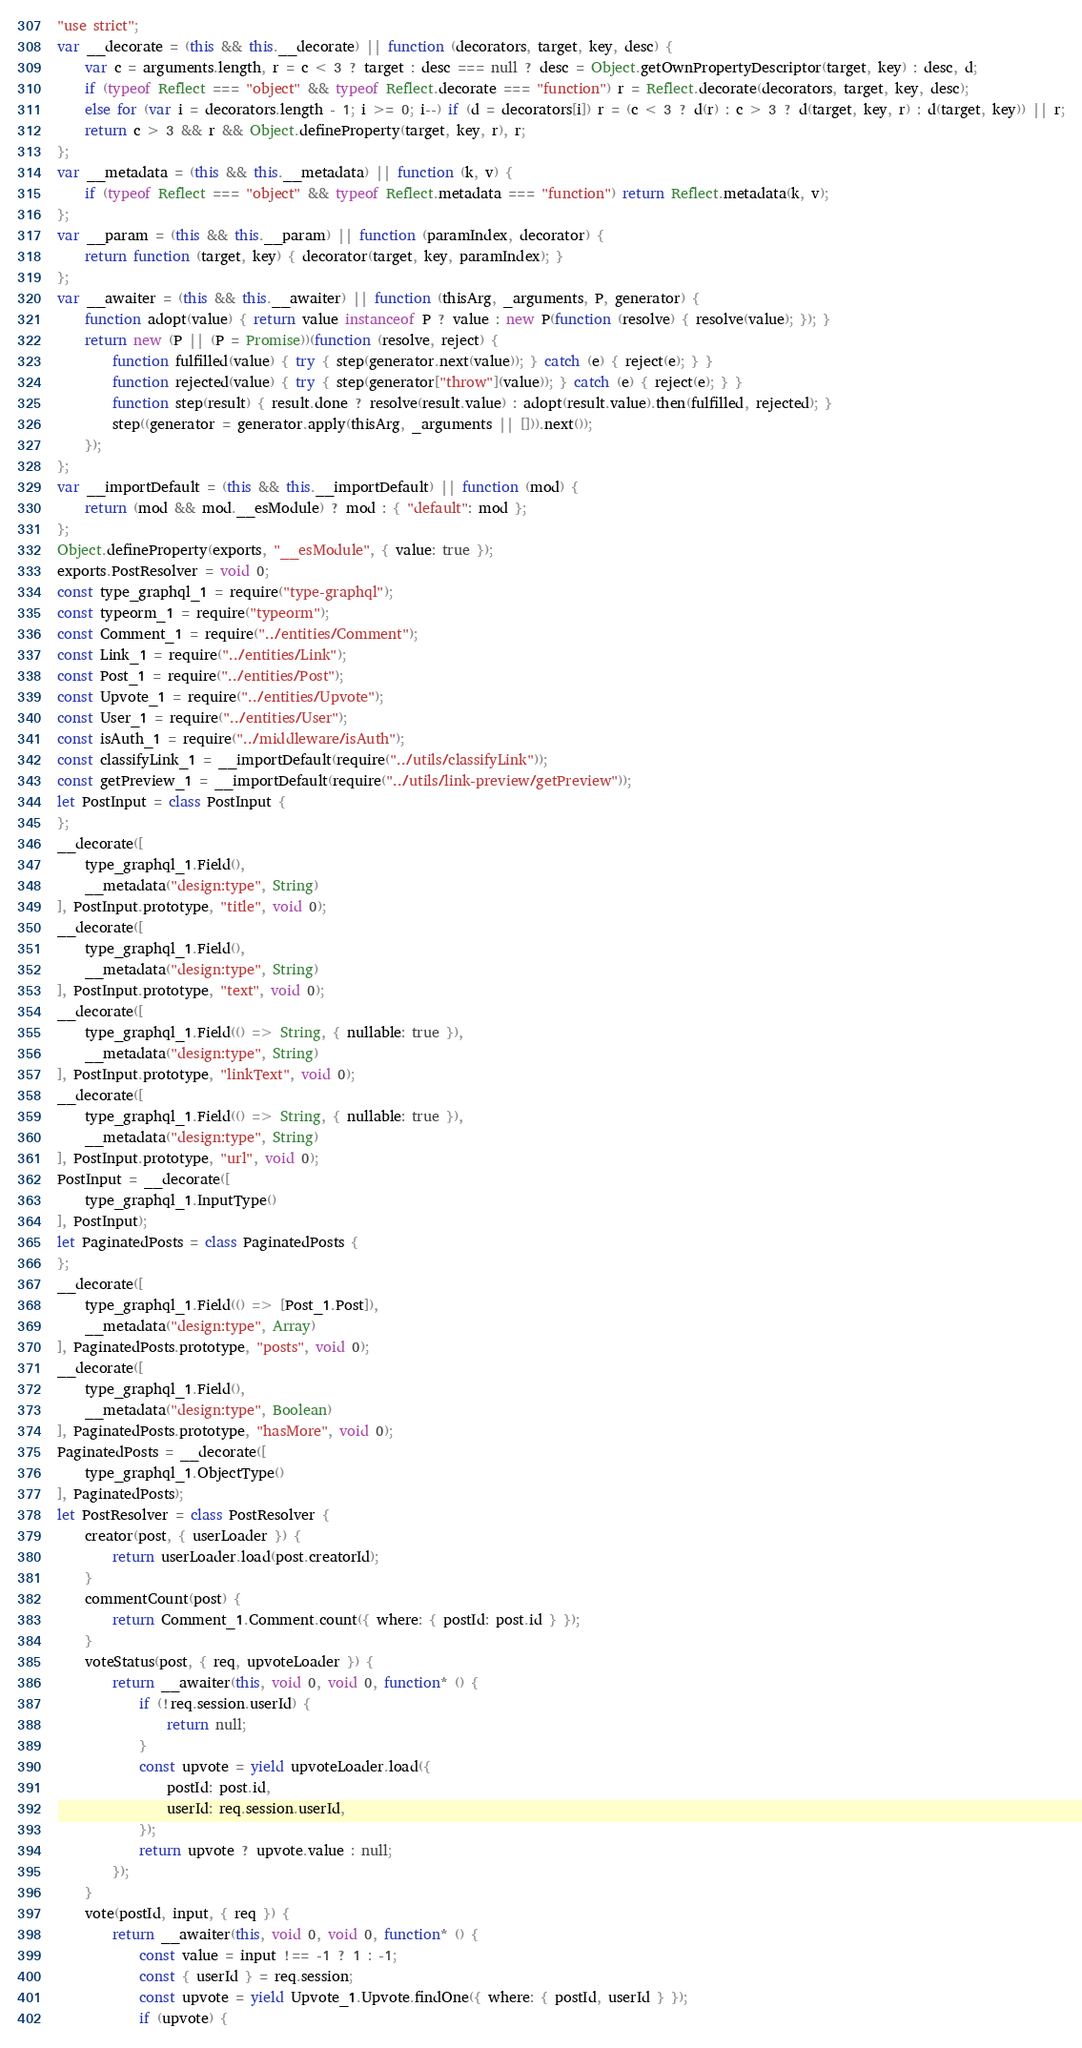Convert code to text. <code><loc_0><loc_0><loc_500><loc_500><_JavaScript_>"use strict";
var __decorate = (this && this.__decorate) || function (decorators, target, key, desc) {
    var c = arguments.length, r = c < 3 ? target : desc === null ? desc = Object.getOwnPropertyDescriptor(target, key) : desc, d;
    if (typeof Reflect === "object" && typeof Reflect.decorate === "function") r = Reflect.decorate(decorators, target, key, desc);
    else for (var i = decorators.length - 1; i >= 0; i--) if (d = decorators[i]) r = (c < 3 ? d(r) : c > 3 ? d(target, key, r) : d(target, key)) || r;
    return c > 3 && r && Object.defineProperty(target, key, r), r;
};
var __metadata = (this && this.__metadata) || function (k, v) {
    if (typeof Reflect === "object" && typeof Reflect.metadata === "function") return Reflect.metadata(k, v);
};
var __param = (this && this.__param) || function (paramIndex, decorator) {
    return function (target, key) { decorator(target, key, paramIndex); }
};
var __awaiter = (this && this.__awaiter) || function (thisArg, _arguments, P, generator) {
    function adopt(value) { return value instanceof P ? value : new P(function (resolve) { resolve(value); }); }
    return new (P || (P = Promise))(function (resolve, reject) {
        function fulfilled(value) { try { step(generator.next(value)); } catch (e) { reject(e); } }
        function rejected(value) { try { step(generator["throw"](value)); } catch (e) { reject(e); } }
        function step(result) { result.done ? resolve(result.value) : adopt(result.value).then(fulfilled, rejected); }
        step((generator = generator.apply(thisArg, _arguments || [])).next());
    });
};
var __importDefault = (this && this.__importDefault) || function (mod) {
    return (mod && mod.__esModule) ? mod : { "default": mod };
};
Object.defineProperty(exports, "__esModule", { value: true });
exports.PostResolver = void 0;
const type_graphql_1 = require("type-graphql");
const typeorm_1 = require("typeorm");
const Comment_1 = require("../entities/Comment");
const Link_1 = require("../entities/Link");
const Post_1 = require("../entities/Post");
const Upvote_1 = require("../entities/Upvote");
const User_1 = require("../entities/User");
const isAuth_1 = require("../middleware/isAuth");
const classifyLink_1 = __importDefault(require("../utils/classifyLink"));
const getPreview_1 = __importDefault(require("../utils/link-preview/getPreview"));
let PostInput = class PostInput {
};
__decorate([
    type_graphql_1.Field(),
    __metadata("design:type", String)
], PostInput.prototype, "title", void 0);
__decorate([
    type_graphql_1.Field(),
    __metadata("design:type", String)
], PostInput.prototype, "text", void 0);
__decorate([
    type_graphql_1.Field(() => String, { nullable: true }),
    __metadata("design:type", String)
], PostInput.prototype, "linkText", void 0);
__decorate([
    type_graphql_1.Field(() => String, { nullable: true }),
    __metadata("design:type", String)
], PostInput.prototype, "url", void 0);
PostInput = __decorate([
    type_graphql_1.InputType()
], PostInput);
let PaginatedPosts = class PaginatedPosts {
};
__decorate([
    type_graphql_1.Field(() => [Post_1.Post]),
    __metadata("design:type", Array)
], PaginatedPosts.prototype, "posts", void 0);
__decorate([
    type_graphql_1.Field(),
    __metadata("design:type", Boolean)
], PaginatedPosts.prototype, "hasMore", void 0);
PaginatedPosts = __decorate([
    type_graphql_1.ObjectType()
], PaginatedPosts);
let PostResolver = class PostResolver {
    creator(post, { userLoader }) {
        return userLoader.load(post.creatorId);
    }
    commentCount(post) {
        return Comment_1.Comment.count({ where: { postId: post.id } });
    }
    voteStatus(post, { req, upvoteLoader }) {
        return __awaiter(this, void 0, void 0, function* () {
            if (!req.session.userId) {
                return null;
            }
            const upvote = yield upvoteLoader.load({
                postId: post.id,
                userId: req.session.userId,
            });
            return upvote ? upvote.value : null;
        });
    }
    vote(postId, input, { req }) {
        return __awaiter(this, void 0, void 0, function* () {
            const value = input !== -1 ? 1 : -1;
            const { userId } = req.session;
            const upvote = yield Upvote_1.Upvote.findOne({ where: { postId, userId } });
            if (upvote) {</code> 